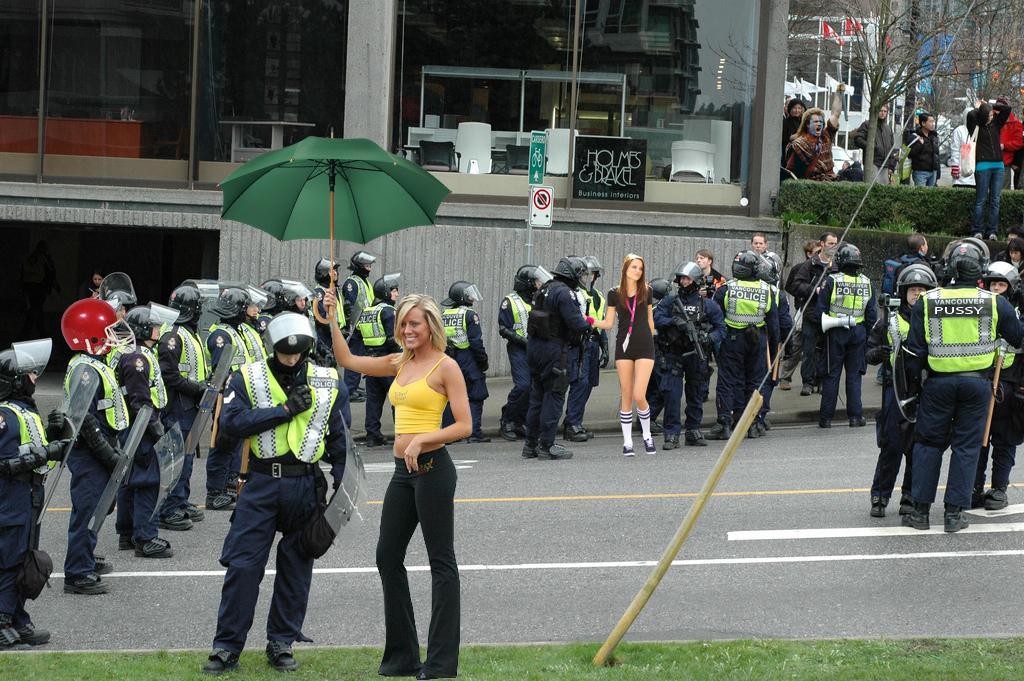In one or two sentences, can you explain what this image depicts? In this picture there is a woman wearing yellow dress is standing on a greenery ground and holding an umbrella in her hand and there are few other persons standing behind her and there is a glass building in the background and there are few trees in the right top corner. 